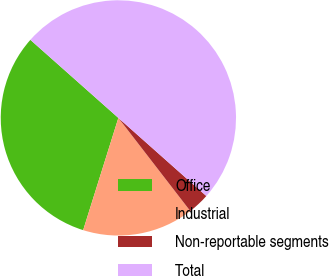Convert chart. <chart><loc_0><loc_0><loc_500><loc_500><pie_chart><fcel>Office<fcel>Industrial<fcel>Non-reportable segments<fcel>Total<nl><fcel>31.71%<fcel>15.3%<fcel>2.98%<fcel>50.0%<nl></chart> 